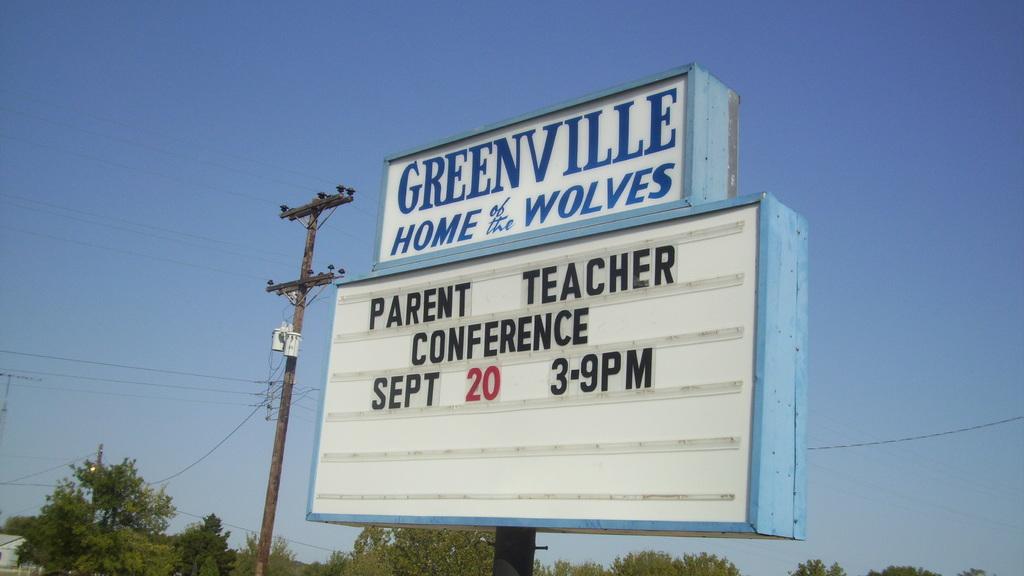What time is the parent teacher conference?
Your answer should be very brief. 3-9 pm. 